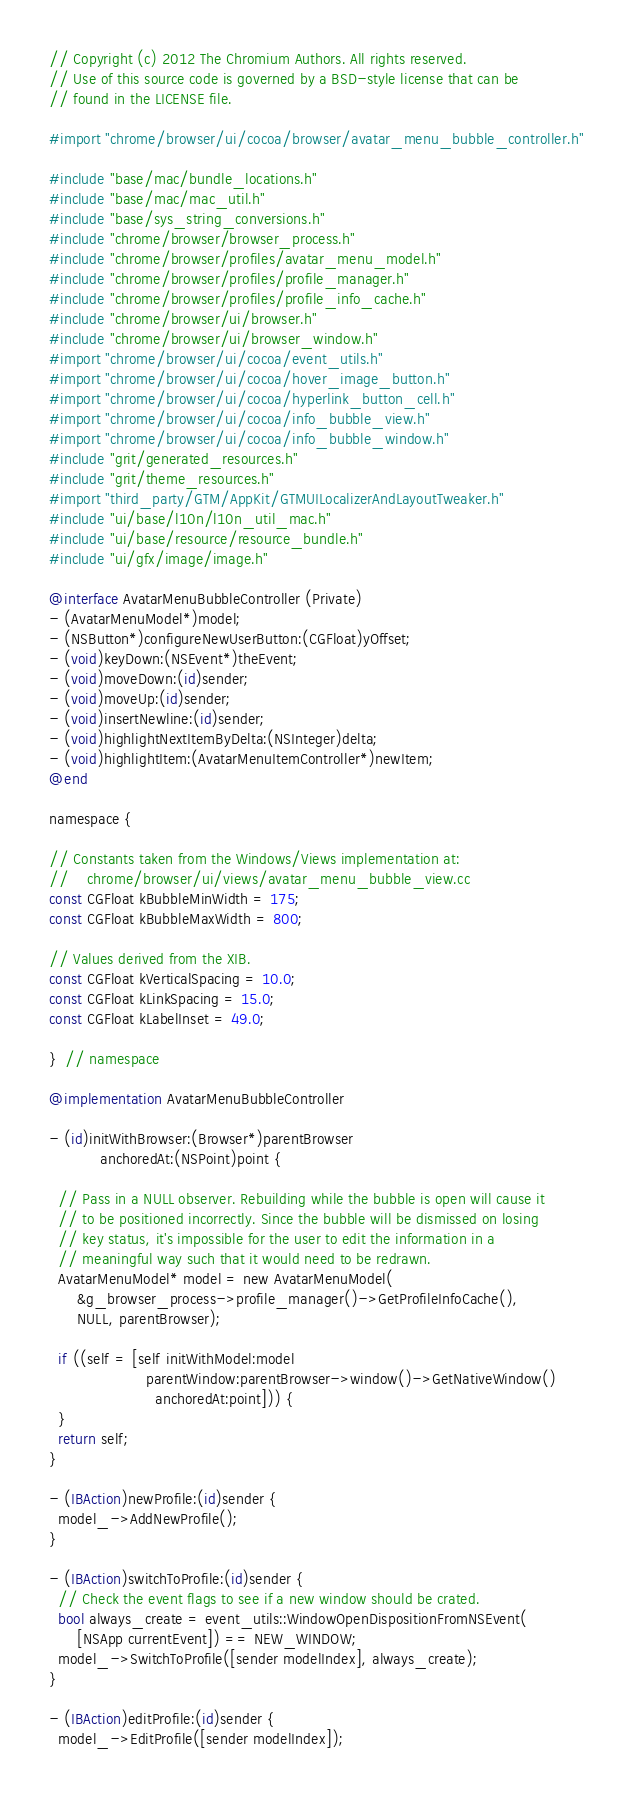<code> <loc_0><loc_0><loc_500><loc_500><_ObjectiveC_>// Copyright (c) 2012 The Chromium Authors. All rights reserved.
// Use of this source code is governed by a BSD-style license that can be
// found in the LICENSE file.

#import "chrome/browser/ui/cocoa/browser/avatar_menu_bubble_controller.h"

#include "base/mac/bundle_locations.h"
#include "base/mac/mac_util.h"
#include "base/sys_string_conversions.h"
#include "chrome/browser/browser_process.h"
#include "chrome/browser/profiles/avatar_menu_model.h"
#include "chrome/browser/profiles/profile_manager.h"
#include "chrome/browser/profiles/profile_info_cache.h"
#include "chrome/browser/ui/browser.h"
#include "chrome/browser/ui/browser_window.h"
#import "chrome/browser/ui/cocoa/event_utils.h"
#import "chrome/browser/ui/cocoa/hover_image_button.h"
#import "chrome/browser/ui/cocoa/hyperlink_button_cell.h"
#import "chrome/browser/ui/cocoa/info_bubble_view.h"
#import "chrome/browser/ui/cocoa/info_bubble_window.h"
#include "grit/generated_resources.h"
#include "grit/theme_resources.h"
#import "third_party/GTM/AppKit/GTMUILocalizerAndLayoutTweaker.h"
#include "ui/base/l10n/l10n_util_mac.h"
#include "ui/base/resource/resource_bundle.h"
#include "ui/gfx/image/image.h"

@interface AvatarMenuBubbleController (Private)
- (AvatarMenuModel*)model;
- (NSButton*)configureNewUserButton:(CGFloat)yOffset;
- (void)keyDown:(NSEvent*)theEvent;
- (void)moveDown:(id)sender;
- (void)moveUp:(id)sender;
- (void)insertNewline:(id)sender;
- (void)highlightNextItemByDelta:(NSInteger)delta;
- (void)highlightItem:(AvatarMenuItemController*)newItem;
@end

namespace {

// Constants taken from the Windows/Views implementation at:
//    chrome/browser/ui/views/avatar_menu_bubble_view.cc
const CGFloat kBubbleMinWidth = 175;
const CGFloat kBubbleMaxWidth = 800;

// Values derived from the XIB.
const CGFloat kVerticalSpacing = 10.0;
const CGFloat kLinkSpacing = 15.0;
const CGFloat kLabelInset = 49.0;

}  // namespace

@implementation AvatarMenuBubbleController

- (id)initWithBrowser:(Browser*)parentBrowser
           anchoredAt:(NSPoint)point {

  // Pass in a NULL observer. Rebuilding while the bubble is open will cause it
  // to be positioned incorrectly. Since the bubble will be dismissed on losing
  // key status, it's impossible for the user to edit the information in a
  // meaningful way such that it would need to be redrawn.
  AvatarMenuModel* model = new AvatarMenuModel(
      &g_browser_process->profile_manager()->GetProfileInfoCache(),
      NULL, parentBrowser);

  if ((self = [self initWithModel:model
                     parentWindow:parentBrowser->window()->GetNativeWindow()
                       anchoredAt:point])) {
  }
  return self;
}

- (IBAction)newProfile:(id)sender {
  model_->AddNewProfile();
}

- (IBAction)switchToProfile:(id)sender {
  // Check the event flags to see if a new window should be crated.
  bool always_create = event_utils::WindowOpenDispositionFromNSEvent(
      [NSApp currentEvent]) == NEW_WINDOW;
  model_->SwitchToProfile([sender modelIndex], always_create);
}

- (IBAction)editProfile:(id)sender {
  model_->EditProfile([sender modelIndex]);</code> 